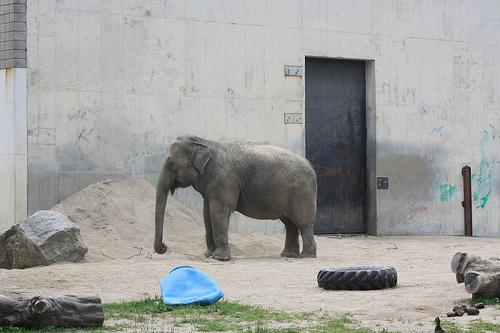Question: what animal is there?
Choices:
A. Cat.
B. Elephant.
C. Dog.
D. Mouse.
Answer with the letter. Answer: B Question: what color is the elephant?
Choices:
A. Grey.
B. Brown.
C. Reddish brown.
D. Blue.
Answer with the letter. Answer: A Question: where is the door?
Choices:
A. On the left.
B. On the right.
C. Behind the bouncer.
D. Behind the elephant.
Answer with the letter. Answer: D 